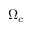<formula> <loc_0><loc_0><loc_500><loc_500>\Omega _ { c }</formula> 